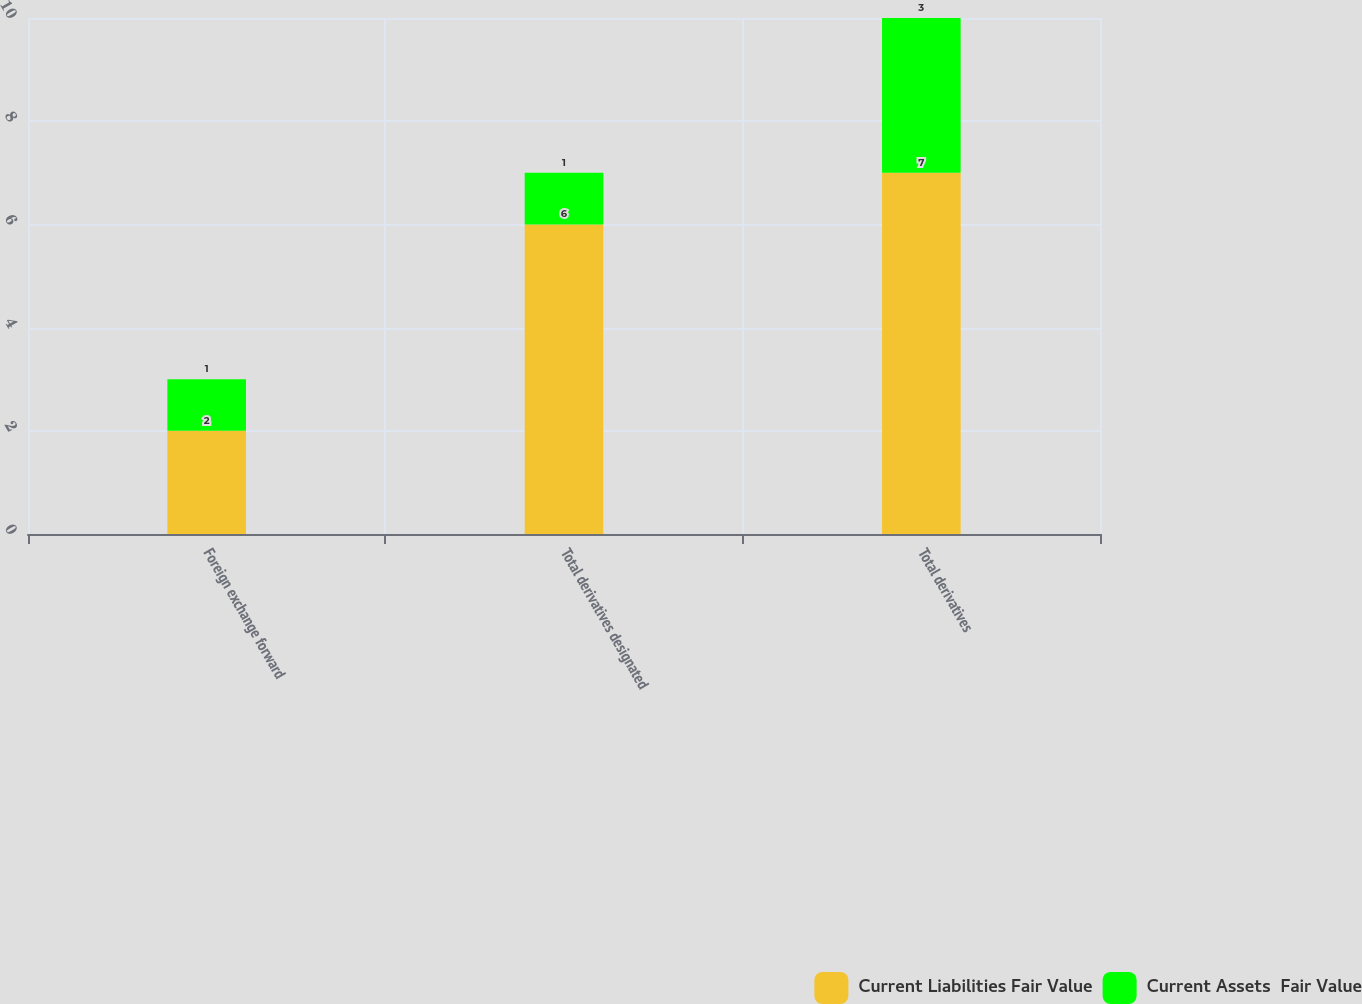<chart> <loc_0><loc_0><loc_500><loc_500><stacked_bar_chart><ecel><fcel>Foreign exchange forward<fcel>Total derivatives designated<fcel>Total derivatives<nl><fcel>Current Liabilities Fair Value<fcel>2<fcel>6<fcel>7<nl><fcel>Current Assets  Fair Value<fcel>1<fcel>1<fcel>3<nl></chart> 